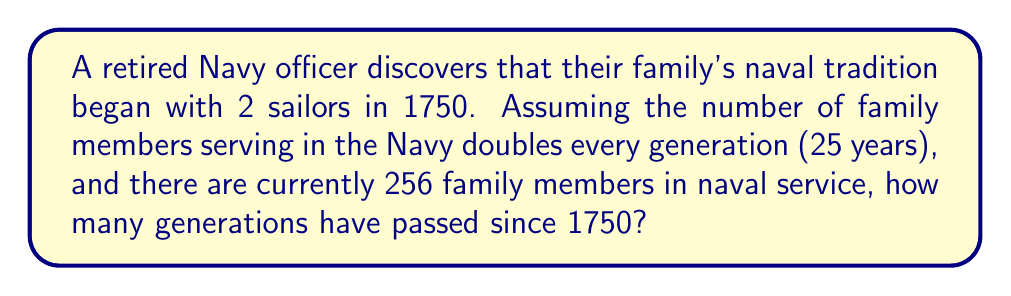Could you help me with this problem? Let's approach this step-by-step using exponential growth:

1) We can model this situation with the exponential equation:
   $$ 256 = 2 \cdot 2^n $$
   Where $n$ is the number of generations.

2) Simplify the right side:
   $$ 256 = 2^{n+1} $$

3) Take the logarithm (base 2) of both sides:
   $$ \log_2(256) = \log_2(2^{n+1}) $$

4) Simplify the right side using the logarithm property $\log_a(a^x) = x$:
   $$ \log_2(256) = n + 1 $$

5) Simplify the left side:
   $$ 8 = n + 1 $$

6) Solve for $n$:
   $$ n = 7 $$

7) Check: $2 \cdot 2^7 = 2 \cdot 128 = 256$, which confirms our result.

8) Calculate the time passed:
   $$ 7 \text{ generations} \cdot 25 \text{ years/generation} = 175 \text{ years} $$

9) Add this to the start year:
   $$ 1750 + 175 = 1925 $$

Thus, 7 generations have passed since 1750, bringing us to approximately 1925.
Answer: 7 generations 